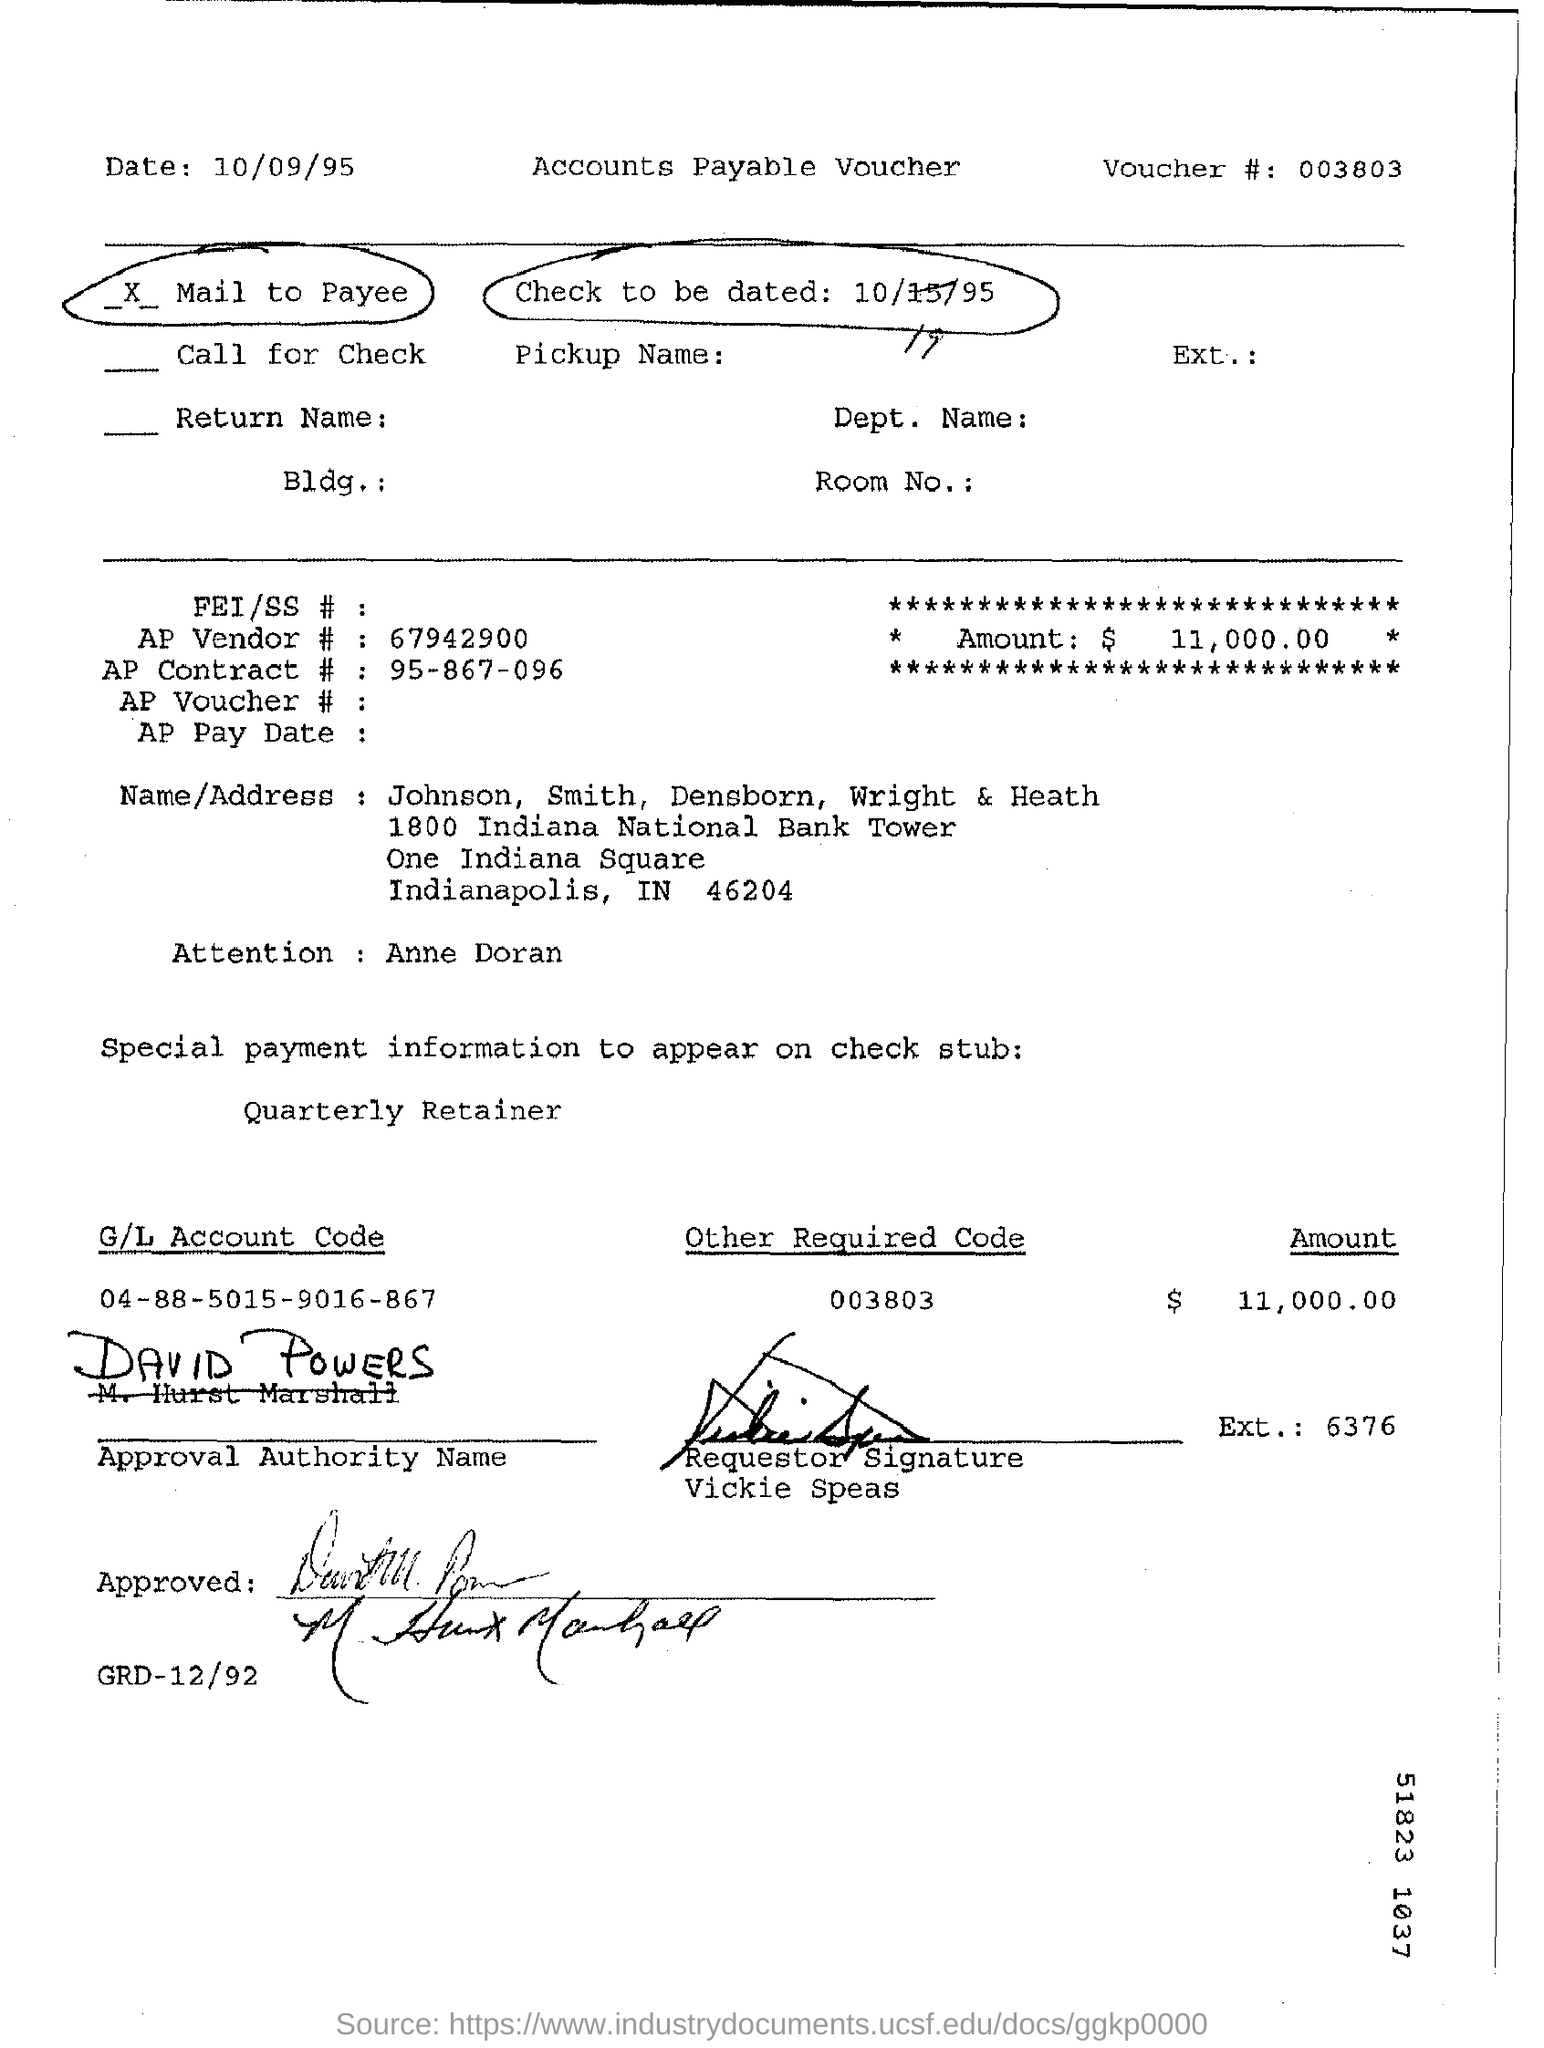What is the voucher number?
Your response must be concise. 003803. What is the amount?
Provide a succinct answer. 11,000.00. What is the AP Vendor number?
Your answer should be very brief. 67942900. Who is the approval authority?
Keep it short and to the point. David Powers. 